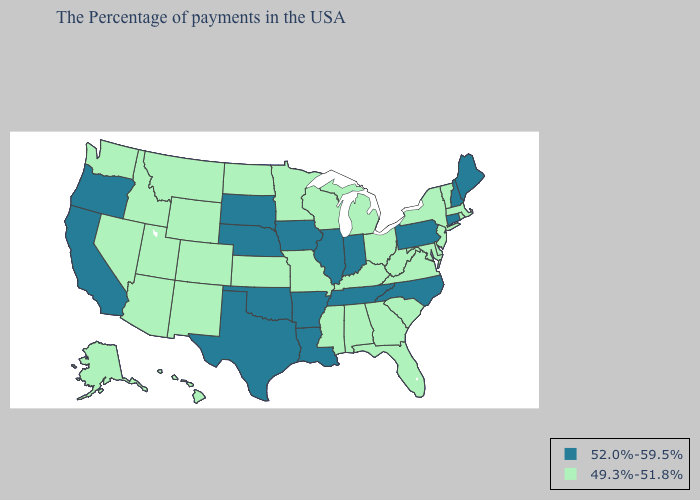What is the value of Montana?
Give a very brief answer. 49.3%-51.8%. Name the states that have a value in the range 52.0%-59.5%?
Give a very brief answer. Maine, New Hampshire, Connecticut, Pennsylvania, North Carolina, Indiana, Tennessee, Illinois, Louisiana, Arkansas, Iowa, Nebraska, Oklahoma, Texas, South Dakota, California, Oregon. Which states have the lowest value in the West?
Answer briefly. Wyoming, Colorado, New Mexico, Utah, Montana, Arizona, Idaho, Nevada, Washington, Alaska, Hawaii. Among the states that border Wisconsin , does Iowa have the lowest value?
Answer briefly. No. What is the lowest value in states that border Nevada?
Write a very short answer. 49.3%-51.8%. Is the legend a continuous bar?
Write a very short answer. No. Does Rhode Island have the same value as Georgia?
Concise answer only. Yes. Name the states that have a value in the range 52.0%-59.5%?
Short answer required. Maine, New Hampshire, Connecticut, Pennsylvania, North Carolina, Indiana, Tennessee, Illinois, Louisiana, Arkansas, Iowa, Nebraska, Oklahoma, Texas, South Dakota, California, Oregon. Does Oregon have a higher value than Nebraska?
Short answer required. No. Does Nebraska have the highest value in the USA?
Short answer required. Yes. What is the value of Kansas?
Write a very short answer. 49.3%-51.8%. Does the first symbol in the legend represent the smallest category?
Short answer required. No. Which states have the highest value in the USA?
Short answer required. Maine, New Hampshire, Connecticut, Pennsylvania, North Carolina, Indiana, Tennessee, Illinois, Louisiana, Arkansas, Iowa, Nebraska, Oklahoma, Texas, South Dakota, California, Oregon. Name the states that have a value in the range 52.0%-59.5%?
Quick response, please. Maine, New Hampshire, Connecticut, Pennsylvania, North Carolina, Indiana, Tennessee, Illinois, Louisiana, Arkansas, Iowa, Nebraska, Oklahoma, Texas, South Dakota, California, Oregon. Name the states that have a value in the range 49.3%-51.8%?
Quick response, please. Massachusetts, Rhode Island, Vermont, New York, New Jersey, Delaware, Maryland, Virginia, South Carolina, West Virginia, Ohio, Florida, Georgia, Michigan, Kentucky, Alabama, Wisconsin, Mississippi, Missouri, Minnesota, Kansas, North Dakota, Wyoming, Colorado, New Mexico, Utah, Montana, Arizona, Idaho, Nevada, Washington, Alaska, Hawaii. 